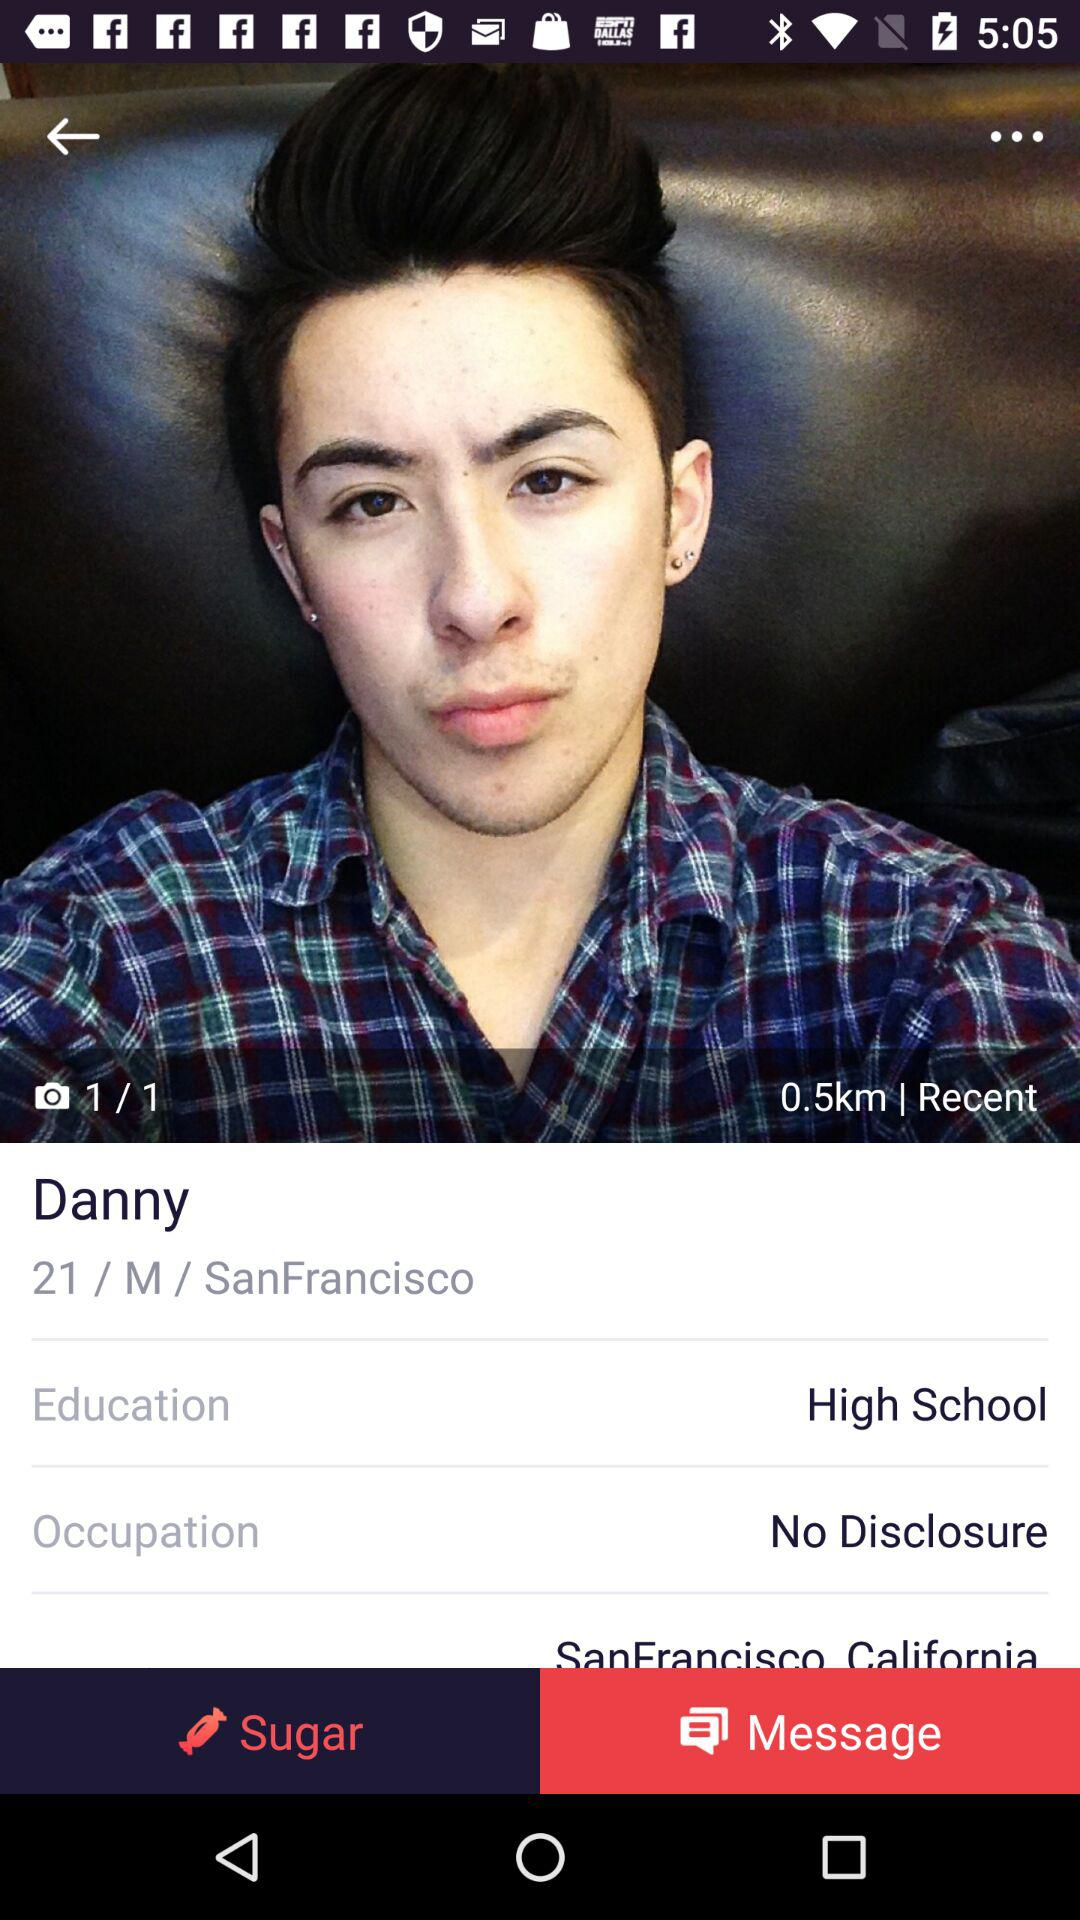What is the location of Danny? The location of Danny is San Francisco. 